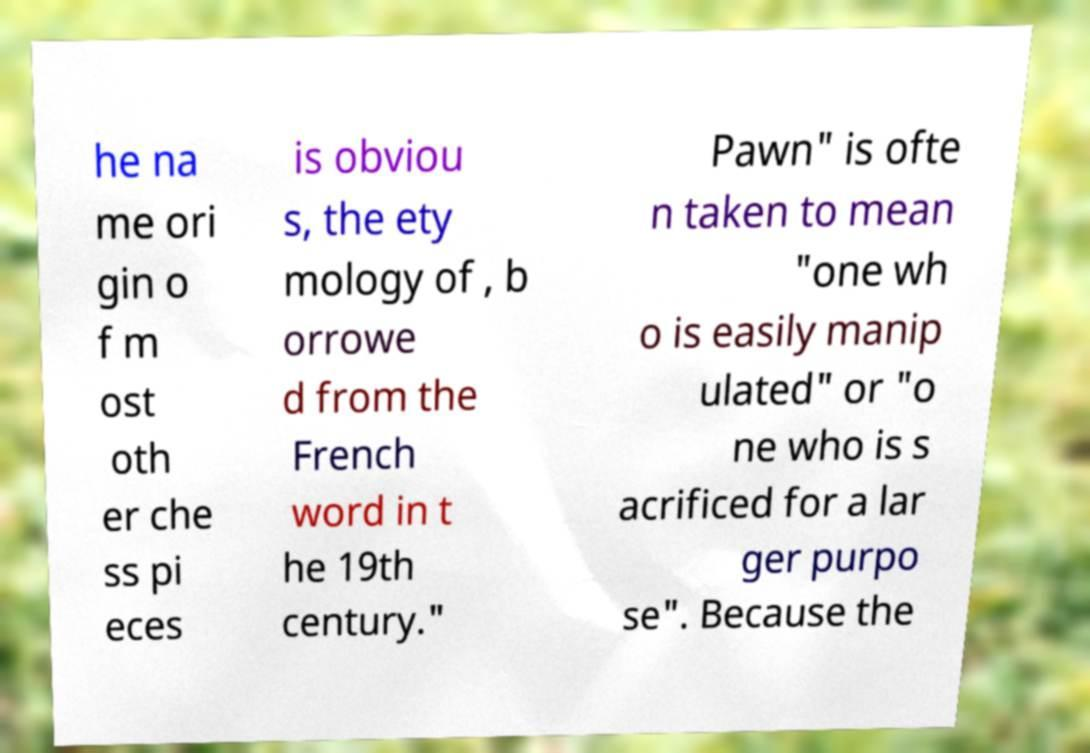What messages or text are displayed in this image? I need them in a readable, typed format. he na me ori gin o f m ost oth er che ss pi eces is obviou s, the ety mology of , b orrowe d from the French word in t he 19th century." Pawn" is ofte n taken to mean "one wh o is easily manip ulated" or "o ne who is s acrificed for a lar ger purpo se". Because the 